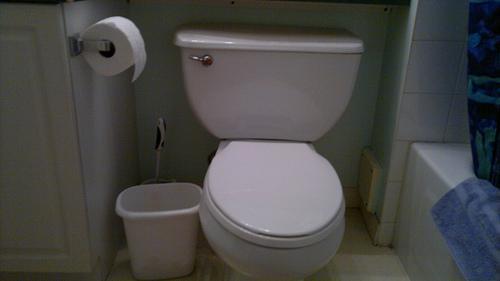How many trash cans are there?
Give a very brief answer. 1. 